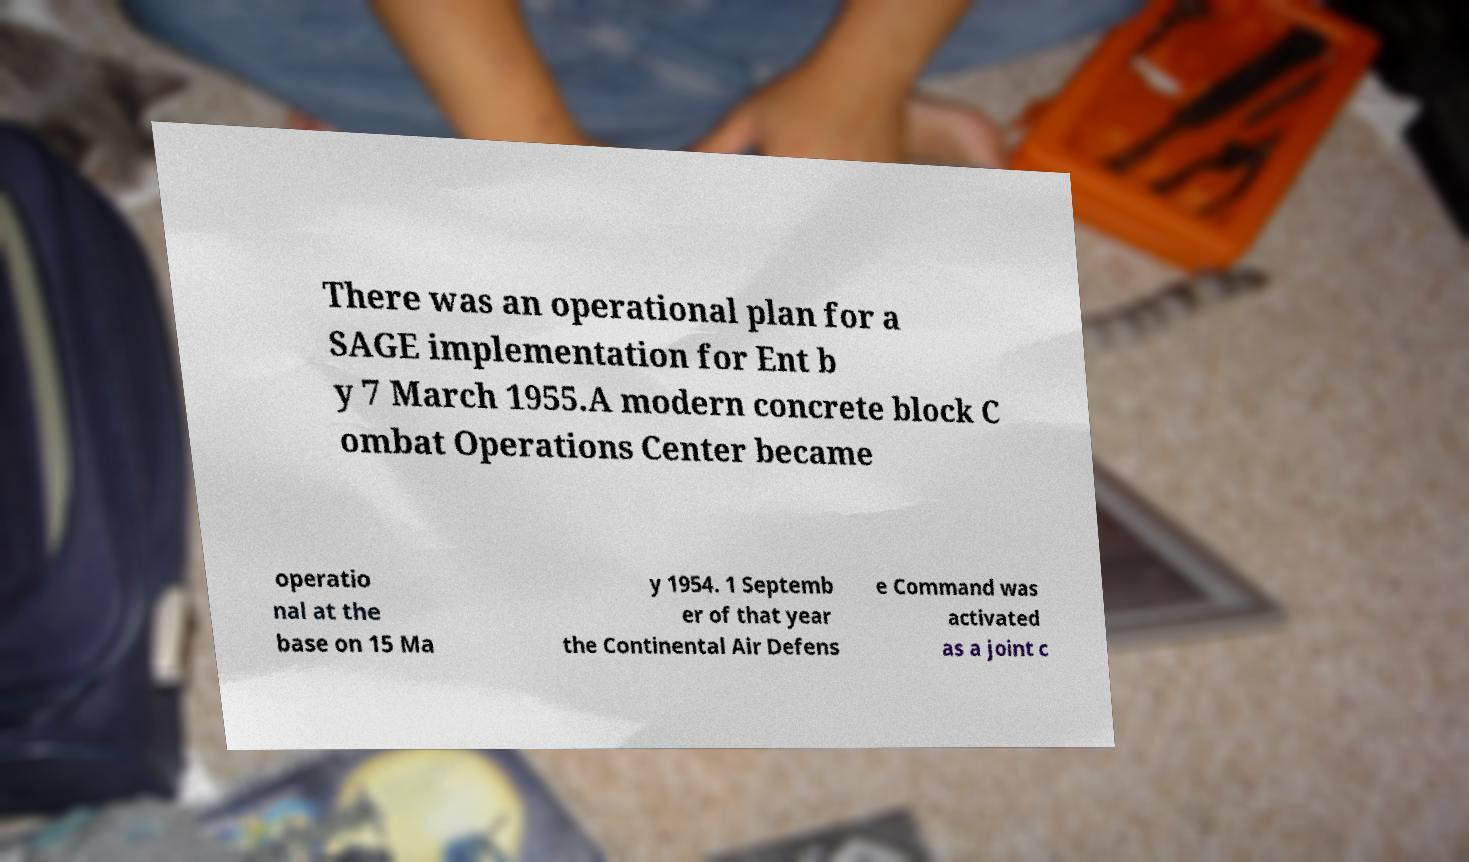Please identify and transcribe the text found in this image. There was an operational plan for a SAGE implementation for Ent b y 7 March 1955.A modern concrete block C ombat Operations Center became operatio nal at the base on 15 Ma y 1954. 1 Septemb er of that year the Continental Air Defens e Command was activated as a joint c 